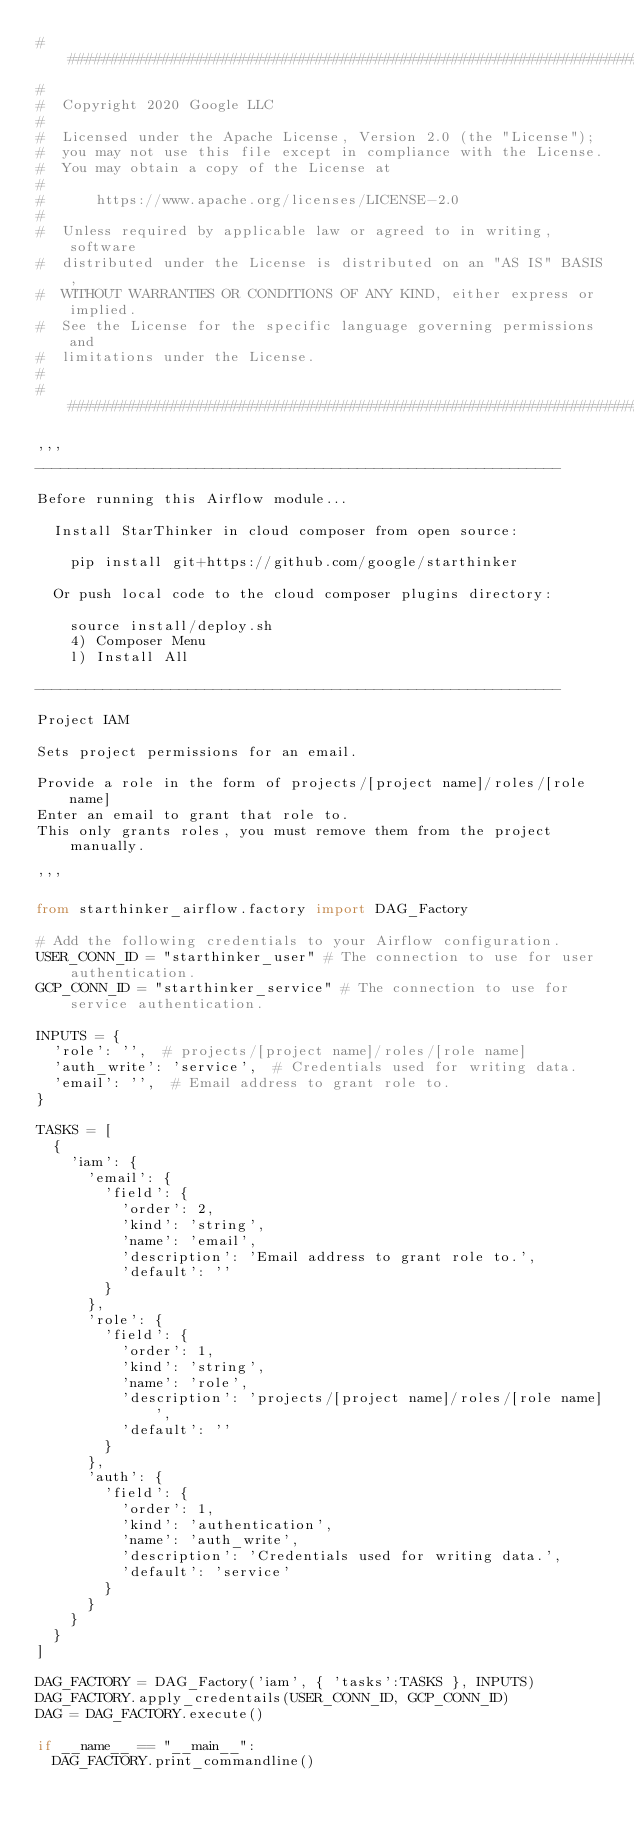Convert code to text. <code><loc_0><loc_0><loc_500><loc_500><_Python_>###########################################################################
#
#  Copyright 2020 Google LLC
#
#  Licensed under the Apache License, Version 2.0 (the "License");
#  you may not use this file except in compliance with the License.
#  You may obtain a copy of the License at
#
#      https://www.apache.org/licenses/LICENSE-2.0
#
#  Unless required by applicable law or agreed to in writing, software
#  distributed under the License is distributed on an "AS IS" BASIS,
#  WITHOUT WARRANTIES OR CONDITIONS OF ANY KIND, either express or implied.
#  See the License for the specific language governing permissions and
#  limitations under the License.
#
###########################################################################

'''
--------------------------------------------------------------

Before running this Airflow module...

  Install StarThinker in cloud composer from open source:

    pip install git+https://github.com/google/starthinker

  Or push local code to the cloud composer plugins directory:

    source install/deploy.sh
    4) Composer Menu
    l) Install All

--------------------------------------------------------------

Project IAM

Sets project permissions for an email.

Provide a role in the form of projects/[project name]/roles/[role name]
Enter an email to grant that role to.
This only grants roles, you must remove them from the project manually.

'''

from starthinker_airflow.factory import DAG_Factory

# Add the following credentials to your Airflow configuration.
USER_CONN_ID = "starthinker_user" # The connection to use for user authentication.
GCP_CONN_ID = "starthinker_service" # The connection to use for service authentication.

INPUTS = {
  'role': '',  # projects/[project name]/roles/[role name]
  'auth_write': 'service',  # Credentials used for writing data.
  'email': '',  # Email address to grant role to.
}

TASKS = [
  {
    'iam': {
      'email': {
        'field': {
          'order': 2,
          'kind': 'string',
          'name': 'email',
          'description': 'Email address to grant role to.',
          'default': ''
        }
      },
      'role': {
        'field': {
          'order': 1,
          'kind': 'string',
          'name': 'role',
          'description': 'projects/[project name]/roles/[role name]',
          'default': ''
        }
      },
      'auth': {
        'field': {
          'order': 1,
          'kind': 'authentication',
          'name': 'auth_write',
          'description': 'Credentials used for writing data.',
          'default': 'service'
        }
      }
    }
  }
]

DAG_FACTORY = DAG_Factory('iam', { 'tasks':TASKS }, INPUTS)
DAG_FACTORY.apply_credentails(USER_CONN_ID, GCP_CONN_ID)
DAG = DAG_FACTORY.execute()

if __name__ == "__main__":
  DAG_FACTORY.print_commandline()
</code> 